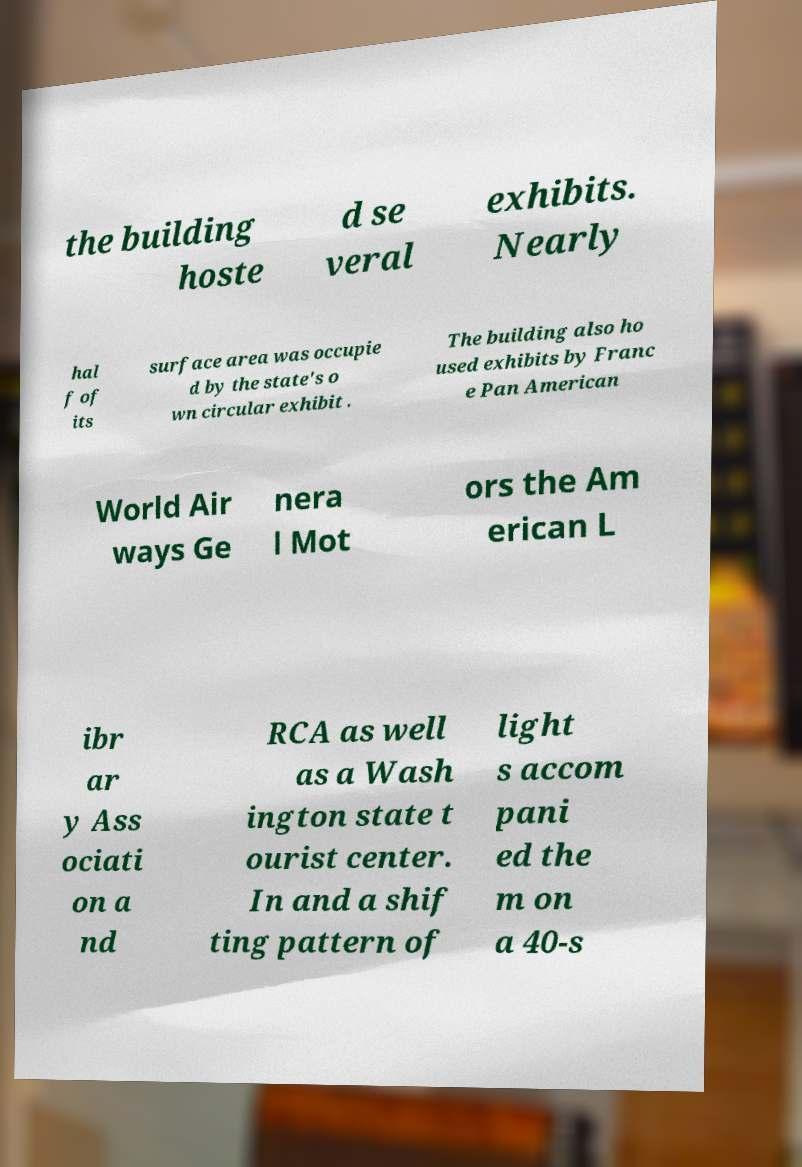Could you extract and type out the text from this image? the building hoste d se veral exhibits. Nearly hal f of its surface area was occupie d by the state's o wn circular exhibit . The building also ho used exhibits by Franc e Pan American World Air ways Ge nera l Mot ors the Am erican L ibr ar y Ass ociati on a nd RCA as well as a Wash ington state t ourist center. In and a shif ting pattern of light s accom pani ed the m on a 40-s 